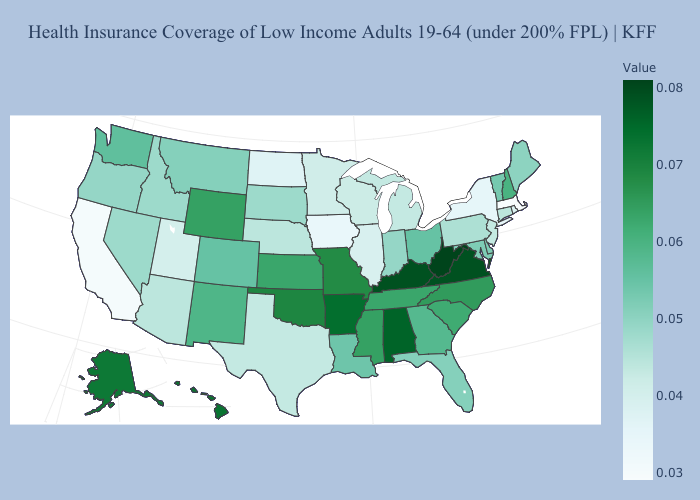Does Idaho have a higher value than North Dakota?
Write a very short answer. Yes. Which states have the highest value in the USA?
Concise answer only. West Virginia. Does Delaware have the lowest value in the USA?
Be succinct. No. Which states hav the highest value in the MidWest?
Keep it brief. Missouri. Among the states that border Florida , does Georgia have the lowest value?
Concise answer only. Yes. Does Alabama have a higher value than Wisconsin?
Concise answer only. Yes. Which states have the highest value in the USA?
Write a very short answer. West Virginia. Does Michigan have a higher value than New Mexico?
Give a very brief answer. No. Does Massachusetts have the lowest value in the USA?
Answer briefly. Yes. Is the legend a continuous bar?
Quick response, please. Yes. Among the states that border Illinois , which have the highest value?
Concise answer only. Kentucky. Is the legend a continuous bar?
Short answer required. Yes. 